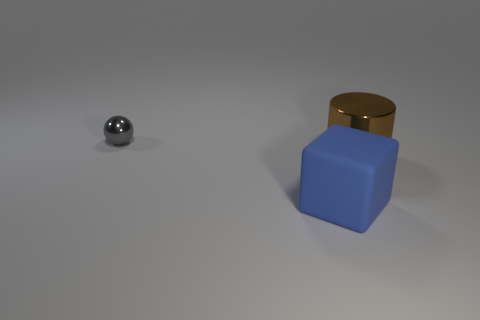The small object has what color?
Provide a short and direct response. Gray. What number of metal objects are either large yellow objects or blue objects?
Offer a very short reply. 0. Is there anything else that has the same material as the tiny object?
Make the answer very short. Yes. There is a metallic object that is to the right of the shiny object on the left side of the cylinder behind the cube; what is its size?
Your answer should be compact. Large. What size is the object that is in front of the small gray object and left of the cylinder?
Keep it short and to the point. Large. There is a large metal thing; how many matte things are behind it?
Make the answer very short. 0. Is there a large brown cylinder that is right of the big object that is to the left of the shiny object that is in front of the gray ball?
Offer a very short reply. Yes. What number of shiny cylinders are the same size as the sphere?
Your response must be concise. 0. There is a object that is behind the shiny object that is right of the gray ball; what is its material?
Keep it short and to the point. Metal. There is a small gray thing that is behind the blue thing in front of the shiny thing that is right of the metallic sphere; what shape is it?
Give a very brief answer. Sphere. 